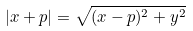<formula> <loc_0><loc_0><loc_500><loc_500>| x + p | = \sqrt { ( x - p ) ^ { 2 } + y ^ { 2 } }</formula> 